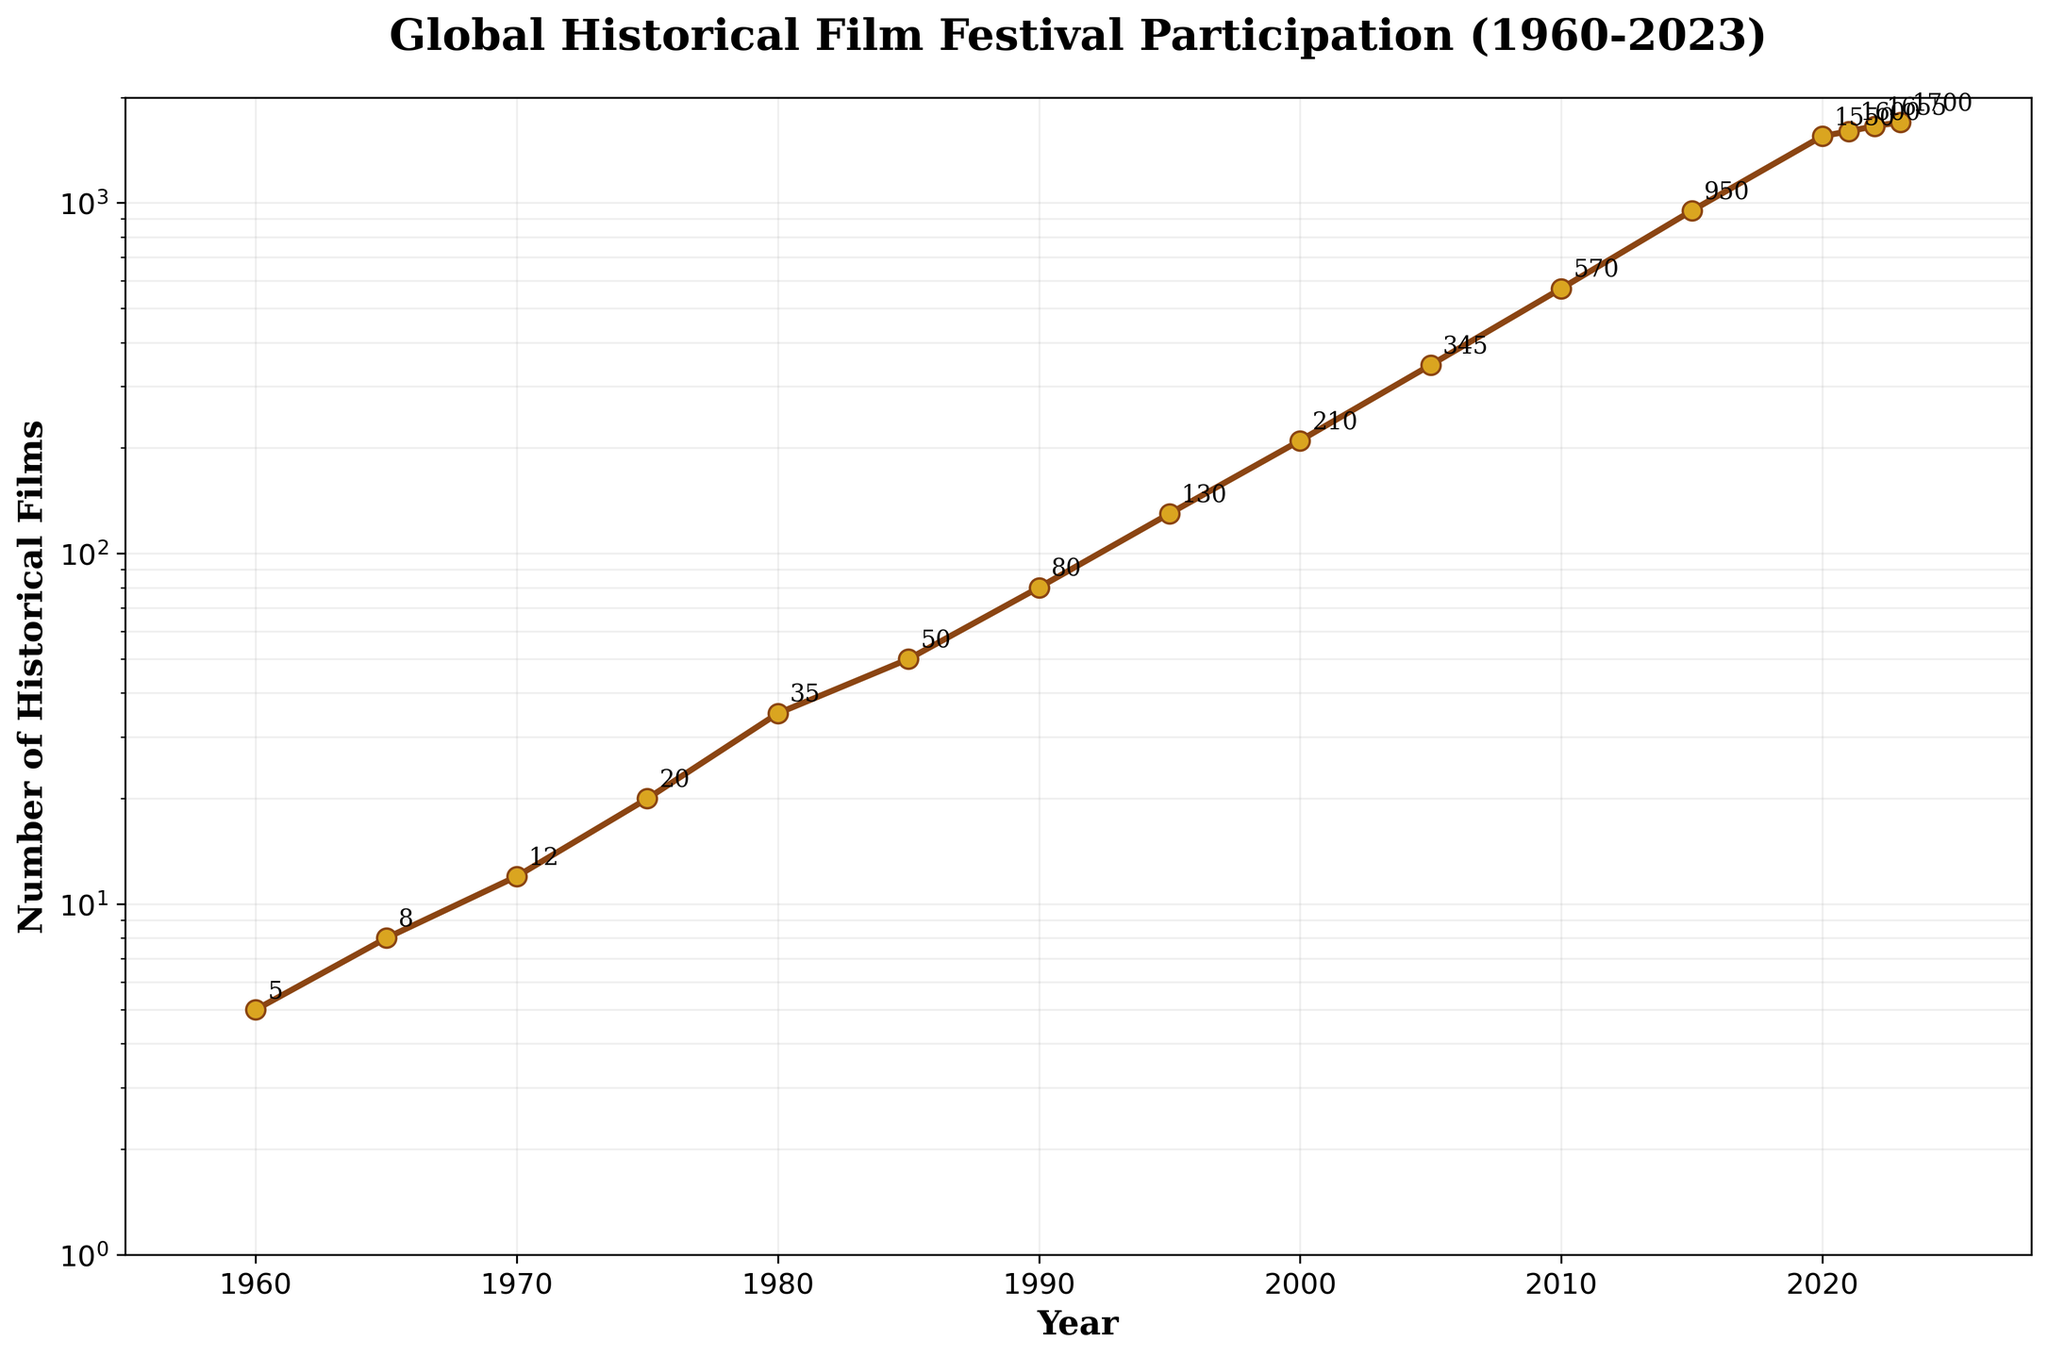What is the title of the plot? The title is displayed at the top of the plot in bold and larger font size. It describes the main subject of the figure.
Answer: Global Historical Film Festival Participation (1960-2023) What is the value of participation in 1980? Locate the year 1980 on the x-axis and follow it up to the line plot. The value for that point is annotated on the plot.
Answer: 35 How many data points are displayed in the figure? Count the number of markers (like dots or circles) on the line plot, which represent the data points.
Answer: 16 In which year did the participation reach 570? Find the point on the plot where the participation value is annotated as 570 and then trace down to the x-axis to find the corresponding year.
Answer: 2010 What is the trend in the number of historical films participating from 1960 to 2023? Observe the line plot from the leftmost to the rightmost point to identify if it is increasing, decreasing, or constant. The line shows a steadily increasing trend.
Answer: Increasing What is the median value of the participation from 1960 to 2023? The median value is the middle data point when all values are arranged in ascending order. For 16 values, it's the average of the 8th and 9th values in the sorted list.
Answer: 105 By how much did the participation increase between 1990 and 2000? Find the values for 1990 (80) and 2000 (210) from the plot and subtract the former from the latter: 210 - 80.
Answer: 130 Which year had the highest increase in participation from the previous year between 2020 and 2023? Calculate the differences in participation between consecutive years: 
2021 - 2020, 2022 - 2021, and 2023 - 2022. Compare these differences. 
1550 to 1600 = 50, 
1600 to 1655 = 55, 
1655 to 1700 = 45. The highest increase is from 2021 to 2022.
Answer: 2022 Is the participation rate higher in 1965 or 1970? Compare the participation values annotated at the years 1965 (8) and 1970 (12).
Answer: 1970 What can you infer from the log scale on the y-axis? The log scale on the y-axis indicates that the participation values vary exponentially, which is evident from the large range of values and the consistent increase over time.
Answer: Values vary exponentially over time 